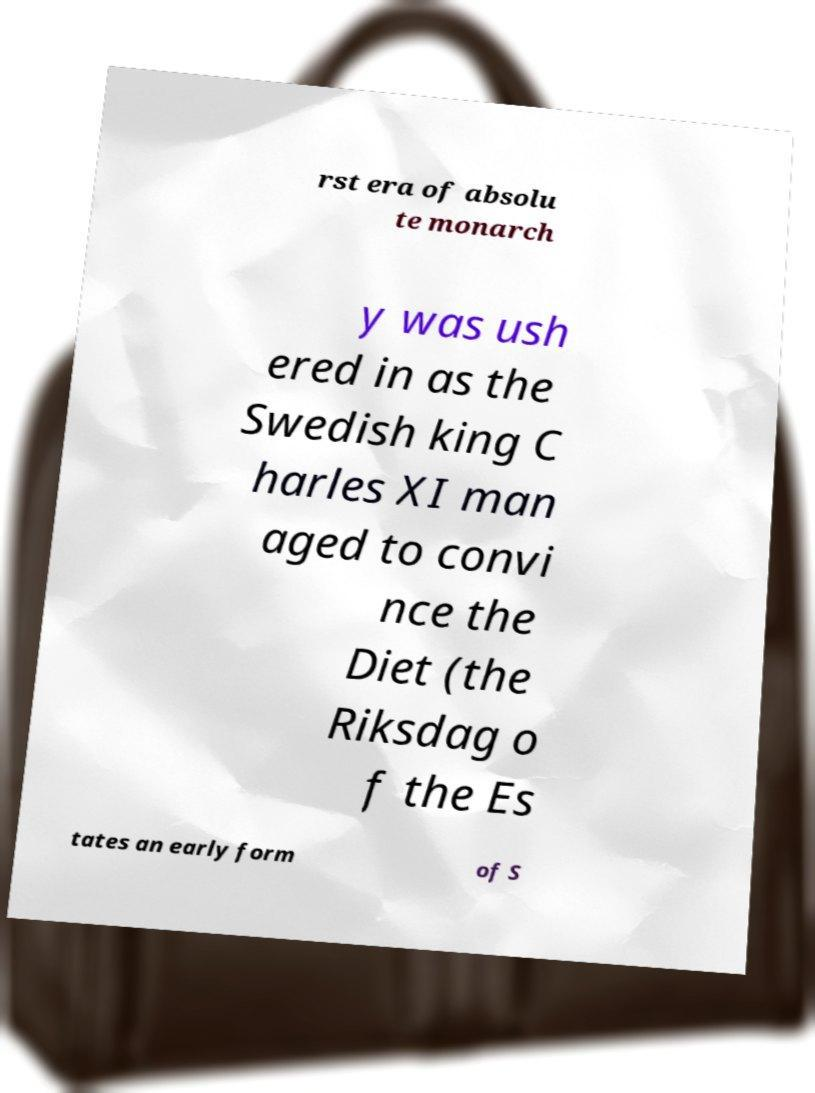For documentation purposes, I need the text within this image transcribed. Could you provide that? rst era of absolu te monarch y was ush ered in as the Swedish king C harles XI man aged to convi nce the Diet (the Riksdag o f the Es tates an early form of S 